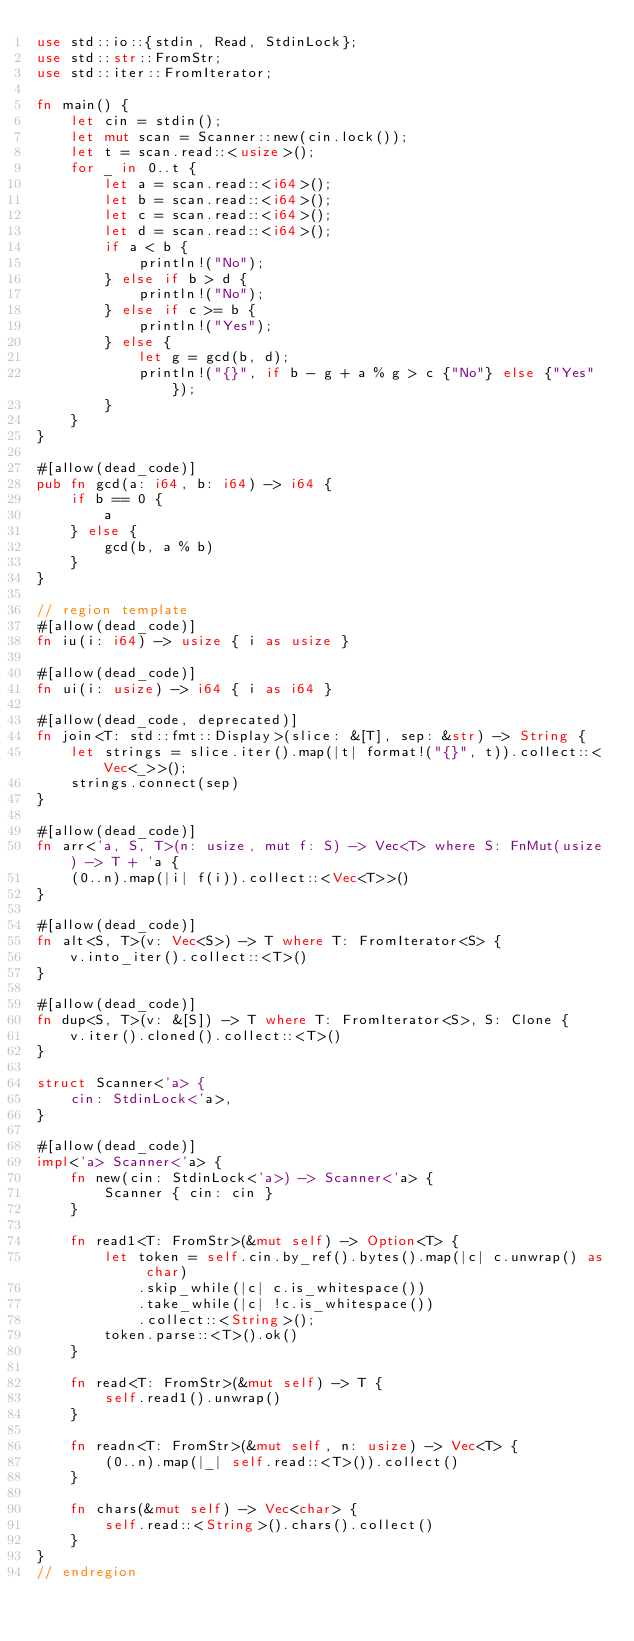Convert code to text. <code><loc_0><loc_0><loc_500><loc_500><_Rust_>use std::io::{stdin, Read, StdinLock};
use std::str::FromStr;
use std::iter::FromIterator;

fn main() {
    let cin = stdin();
    let mut scan = Scanner::new(cin.lock());
    let t = scan.read::<usize>();
    for _ in 0..t {
        let a = scan.read::<i64>();
        let b = scan.read::<i64>();
        let c = scan.read::<i64>();
        let d = scan.read::<i64>();
        if a < b {
            println!("No");
        } else if b > d {
            println!("No");
        } else if c >= b {
            println!("Yes");
        } else {
            let g = gcd(b, d);
            println!("{}", if b - g + a % g > c {"No"} else {"Yes"});
        }
    }
}

#[allow(dead_code)]
pub fn gcd(a: i64, b: i64) -> i64 {
    if b == 0 {
        a
    } else {
        gcd(b, a % b)
    }
}

// region template
#[allow(dead_code)]
fn iu(i: i64) -> usize { i as usize }

#[allow(dead_code)]
fn ui(i: usize) -> i64 { i as i64 }

#[allow(dead_code, deprecated)]
fn join<T: std::fmt::Display>(slice: &[T], sep: &str) -> String {
    let strings = slice.iter().map(|t| format!("{}", t)).collect::<Vec<_>>();
    strings.connect(sep)
}

#[allow(dead_code)]
fn arr<'a, S, T>(n: usize, mut f: S) -> Vec<T> where S: FnMut(usize) -> T + 'a {
    (0..n).map(|i| f(i)).collect::<Vec<T>>()
}

#[allow(dead_code)]
fn alt<S, T>(v: Vec<S>) -> T where T: FromIterator<S> {
    v.into_iter().collect::<T>()
}

#[allow(dead_code)]
fn dup<S, T>(v: &[S]) -> T where T: FromIterator<S>, S: Clone {
    v.iter().cloned().collect::<T>()
}

struct Scanner<'a> {
    cin: StdinLock<'a>,
}

#[allow(dead_code)]
impl<'a> Scanner<'a> {
    fn new(cin: StdinLock<'a>) -> Scanner<'a> {
        Scanner { cin: cin }
    }

    fn read1<T: FromStr>(&mut self) -> Option<T> {
        let token = self.cin.by_ref().bytes().map(|c| c.unwrap() as char)
            .skip_while(|c| c.is_whitespace())
            .take_while(|c| !c.is_whitespace())
            .collect::<String>();
        token.parse::<T>().ok()
    }

    fn read<T: FromStr>(&mut self) -> T {
        self.read1().unwrap()
    }

    fn readn<T: FromStr>(&mut self, n: usize) -> Vec<T> {
        (0..n).map(|_| self.read::<T>()).collect()
    }

    fn chars(&mut self) -> Vec<char> {
        self.read::<String>().chars().collect()
    }
}
// endregion</code> 